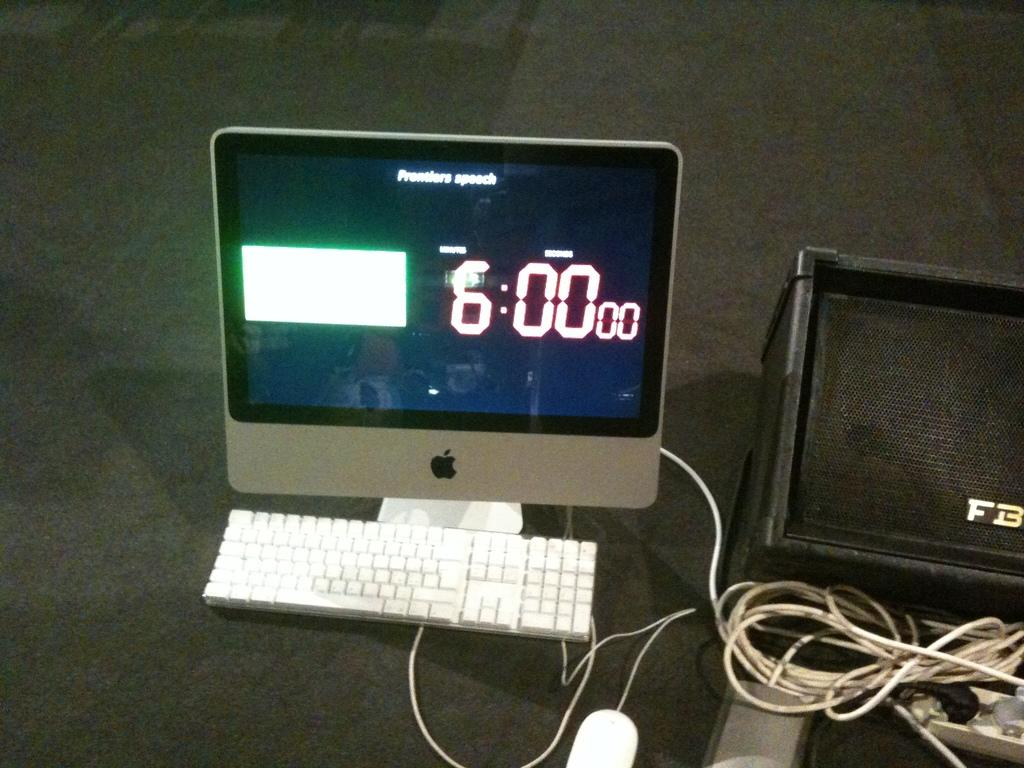<image>
Give a short and clear explanation of the subsequent image. Apple computer monitor showing the timer at 6:00. 